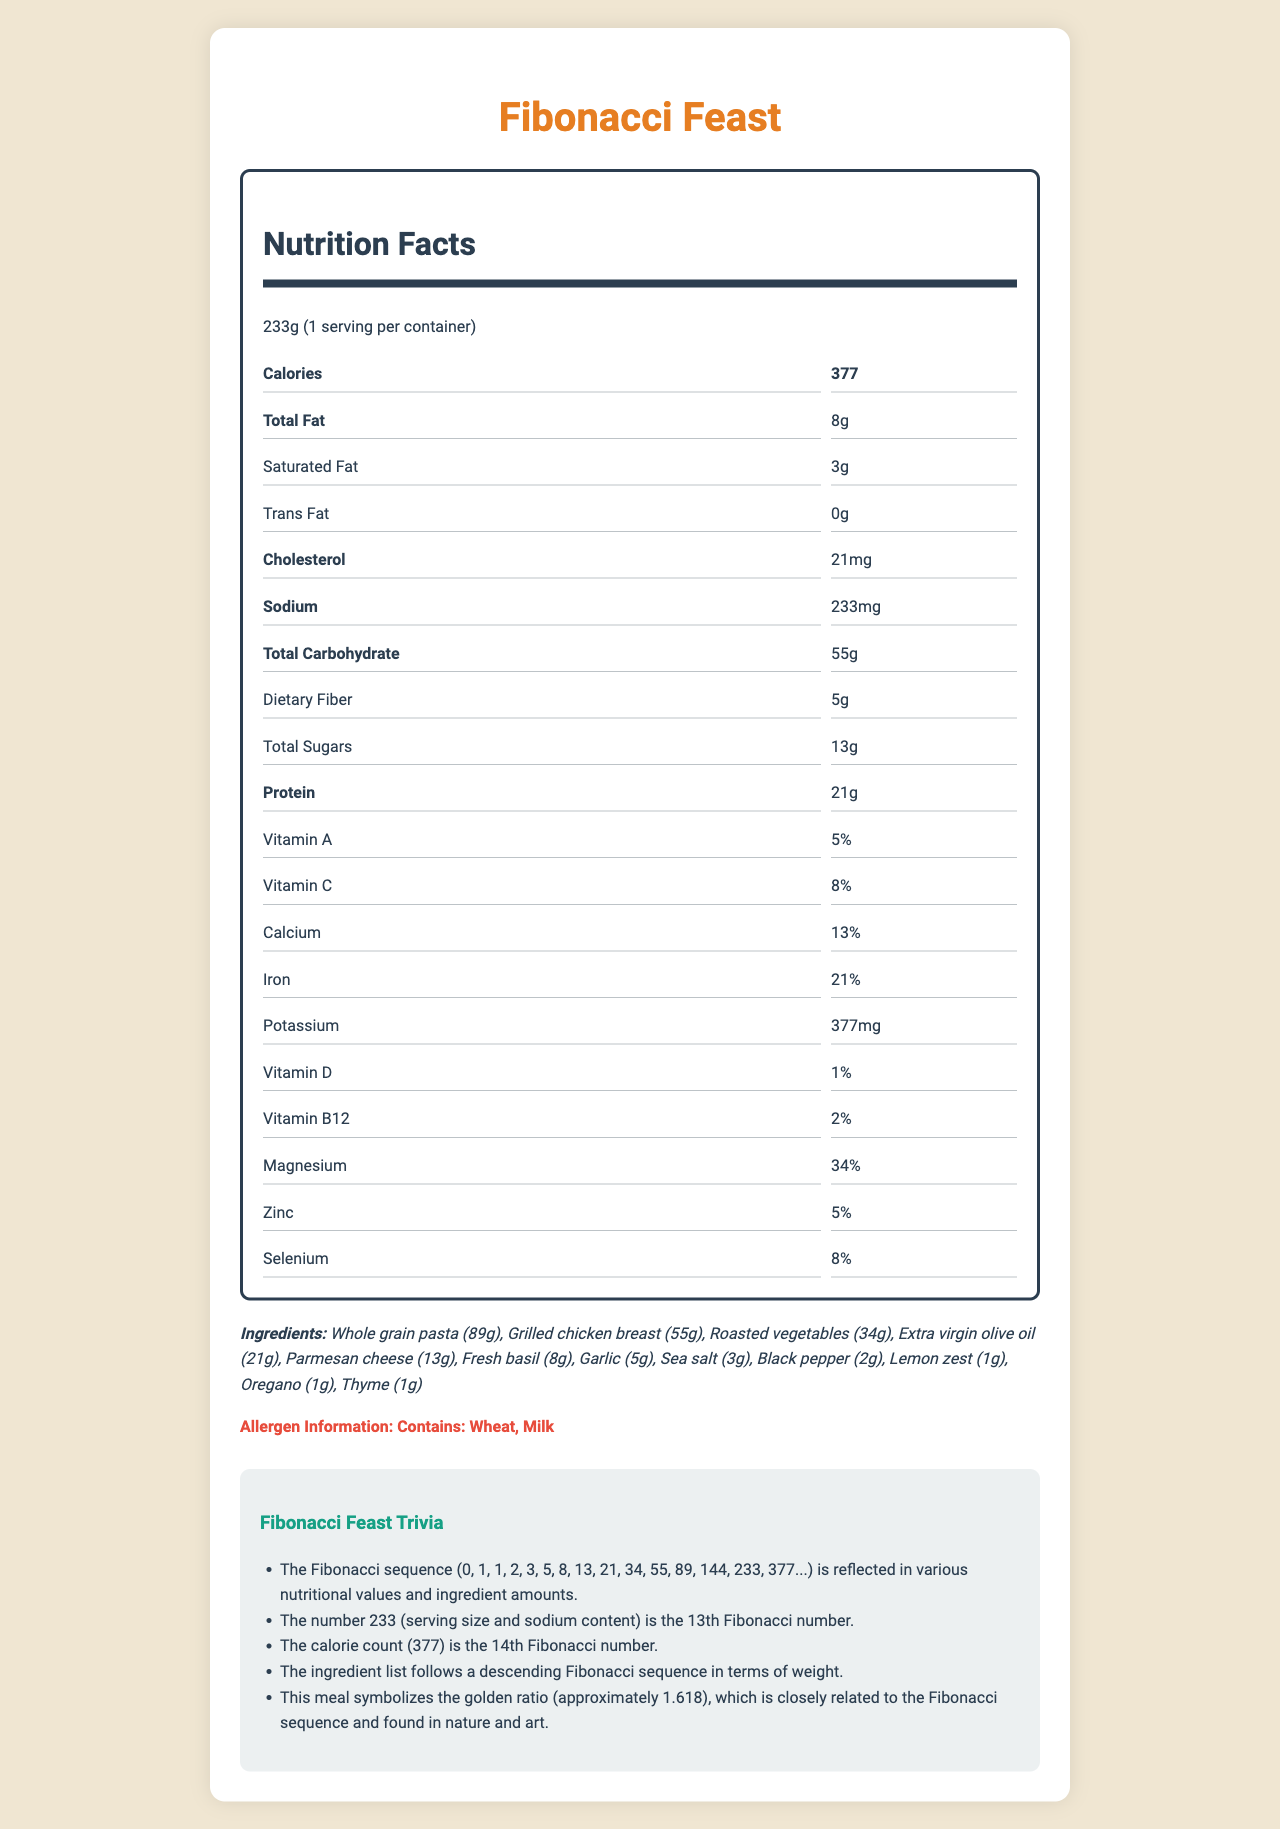what is the serving size of the Fibonacci Feast meal? The serving size is stated at the beginning of the nutrition label as "233g."
Answer: 233g how many servings are in one container of this meal? The label states "1 serving per container."
Answer: 1 how many calories are in one serving of this meal? The label states "Calories: 377."
Answer: 377 how much total fat is in one serving? The label lists "Total Fat: 8g."
Answer: 8g how much sodium does one serving contain? The label states "Sodium: 233mg."
Answer: 233mg which nutrient has the highest daily value percentage? Magnesium has the highest daily value percentage at 34%.
Answer: Magnesium what is the total carbohydrate content in one serving? A. 55g B. 34g C. 21g D. 377g The label lists the "Total Carbohydrate" as 55g.
Answer: A which ingredient is present in the smallest quantity? A. Garlic B. Lemon zest C. Fresh basil D. Thyme Thyme is listed last among the ingredients, indicating it is present in the smallest quantity (1g).
Answer: D does this meal contain trans fat? The label states "Trans Fat: 0g."
Answer: No is there more dietary fiber than total sugars in one serving? The label lists "Dietary Fiber: 5g" and "Total Sugars: 13g," so there are more total sugars than dietary fiber.
Answer: No how does the Fibonacci sequence relate to the nutritional values in the meal? Trivia notes explain the connection to the Fibonacci sequence with examples like the serving size, sodium content, and calories.
Answer: Various nutritional values follow the Fibonacci sequence, such as the serving size (233g), sodium content (233mg), and calorie count (377), signifying specific Fibonacci numbers. what allergens are present in this meal? The allergen information at the bottom of the document states that it contains wheat and milk.
Answer: Wheat and Milk summarize the main idea of this document. The document provides a comprehensive view of the nutritional facts, ingredient list, allergen content, and the unique aspect of using Fibonacci numbers in the ingredient quantities and nutritional values.
Answer: The document is a nutrition facts label for a meal called "Fibonacci Feast." It details the serving size, calories, and nutritional content, all of which follow the Fibonacci sequence. The ingredients list also reflects Fibonacci numbers by weight, and the document includes allergen information and trivia notes about the significance of the Fibonacci sequence. what is the golden ratio and how is it symbolized in this meal? The document mentions that the meal symbolizes the golden ratio, which is closely related to the Fibonacci sequence, but it does not provide further details on how it is symbolized.
Answer: Not enough information how many milligrams of potassium are in one serving of this meal? The nutrition label states "Potassium: 377mg."
Answer: 377mg 